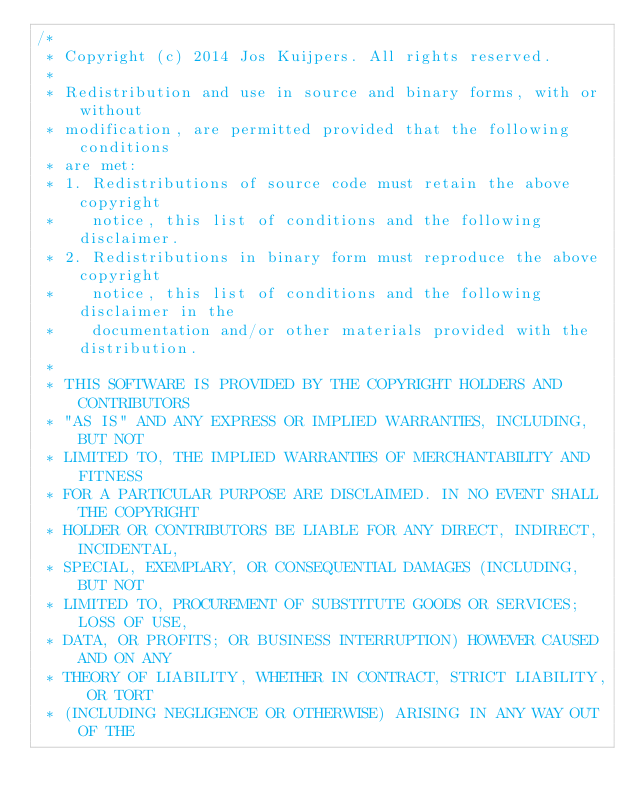Convert code to text. <code><loc_0><loc_0><loc_500><loc_500><_ObjectiveC_>/*
 * Copyright (c) 2014 Jos Kuijpers. All rights reserved.
 *
 * Redistribution and use in source and binary forms, with or without
 * modification, are permitted provided that the following conditions
 * are met:
 * 1. Redistributions of source code must retain the above copyright
 *    notice, this list of conditions and the following disclaimer.
 * 2. Redistributions in binary form must reproduce the above copyright
 *    notice, this list of conditions and the following disclaimer in the
 *    documentation and/or other materials provided with the distribution.
 *
 * THIS SOFTWARE IS PROVIDED BY THE COPYRIGHT HOLDERS AND CONTRIBUTORS
 * "AS IS" AND ANY EXPRESS OR IMPLIED WARRANTIES, INCLUDING, BUT NOT
 * LIMITED TO, THE IMPLIED WARRANTIES OF MERCHANTABILITY AND FITNESS
 * FOR A PARTICULAR PURPOSE ARE DISCLAIMED. IN NO EVENT SHALL THE COPYRIGHT
 * HOLDER OR CONTRIBUTORS BE LIABLE FOR ANY DIRECT, INDIRECT, INCIDENTAL,
 * SPECIAL, EXEMPLARY, OR CONSEQUENTIAL DAMAGES (INCLUDING, BUT NOT
 * LIMITED TO, PROCUREMENT OF SUBSTITUTE GOODS OR SERVICES; LOSS OF USE,
 * DATA, OR PROFITS; OR BUSINESS INTERRUPTION) HOWEVER CAUSED AND ON ANY
 * THEORY OF LIABILITY, WHETHER IN CONTRACT, STRICT LIABILITY, OR TORT
 * (INCLUDING NEGLIGENCE OR OTHERWISE) ARISING IN ANY WAY OUT OF THE</code> 